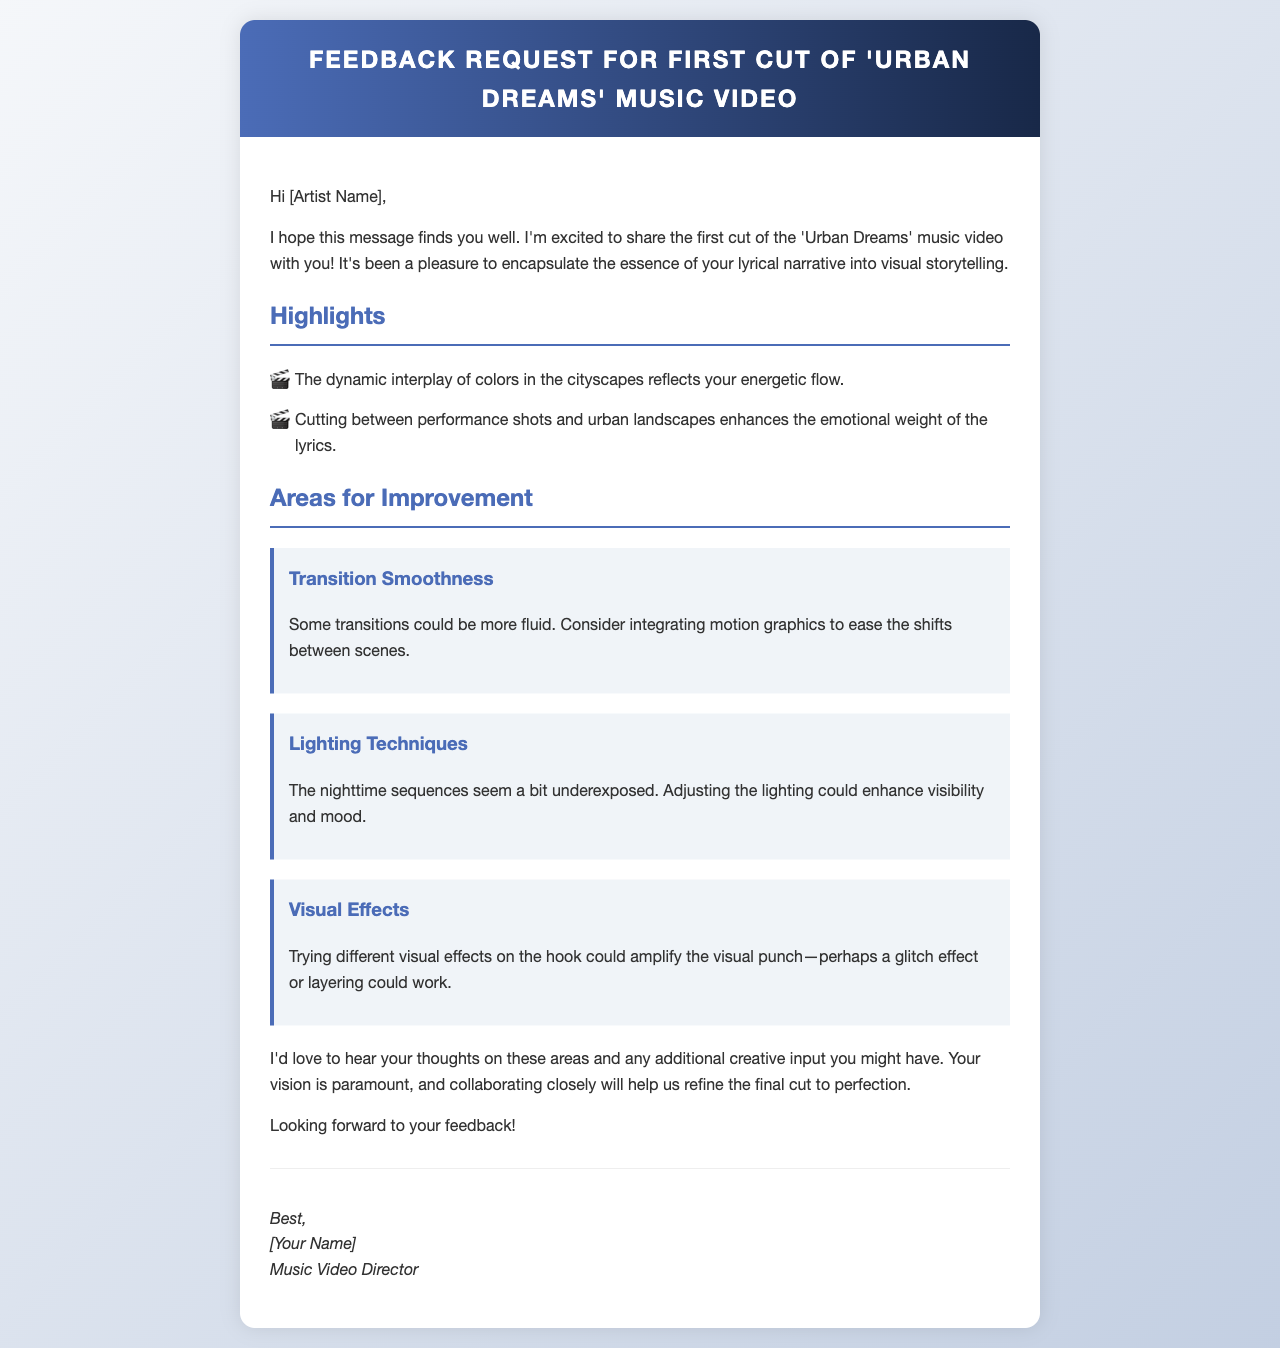What is the title of the music video? The title of the music video is mentioned in the header of the document.
Answer: Urban Dreams Who is the email addressed to? The email begins with a greeting addressing the artist, which indicates the recipient's title.
Answer: [Artist Name] What is one highlight mentioned in the email? The document lists highlights in a bulleted format under the section titled "Highlights."
Answer: The dynamic interplay of colors in the cityscapes reflects your energetic flow What is one area for improvement related to lighting? The content discusses specific areas for improvement, which includes lighting techniques.
Answer: The nighttime sequences seem a bit underexposed What visual effect is suggested for the hook? The email mentions a specific suggestion regarding visual effects for the hook in the section on improvements.
Answer: A glitch effect or layering How many key areas for improvement are listed in the document? By counting the sections under "Areas for Improvement," we can find this number.
Answer: Three What is the tone of the email? Analyzing the language used in the email provides insight into its tone, which is an integral part of communication.
Answer: Collaborative What does the director express excitement about? In the opening paragraph, the director shares their sentiment regarding the project.
Answer: Sharing the first cut of the music video 